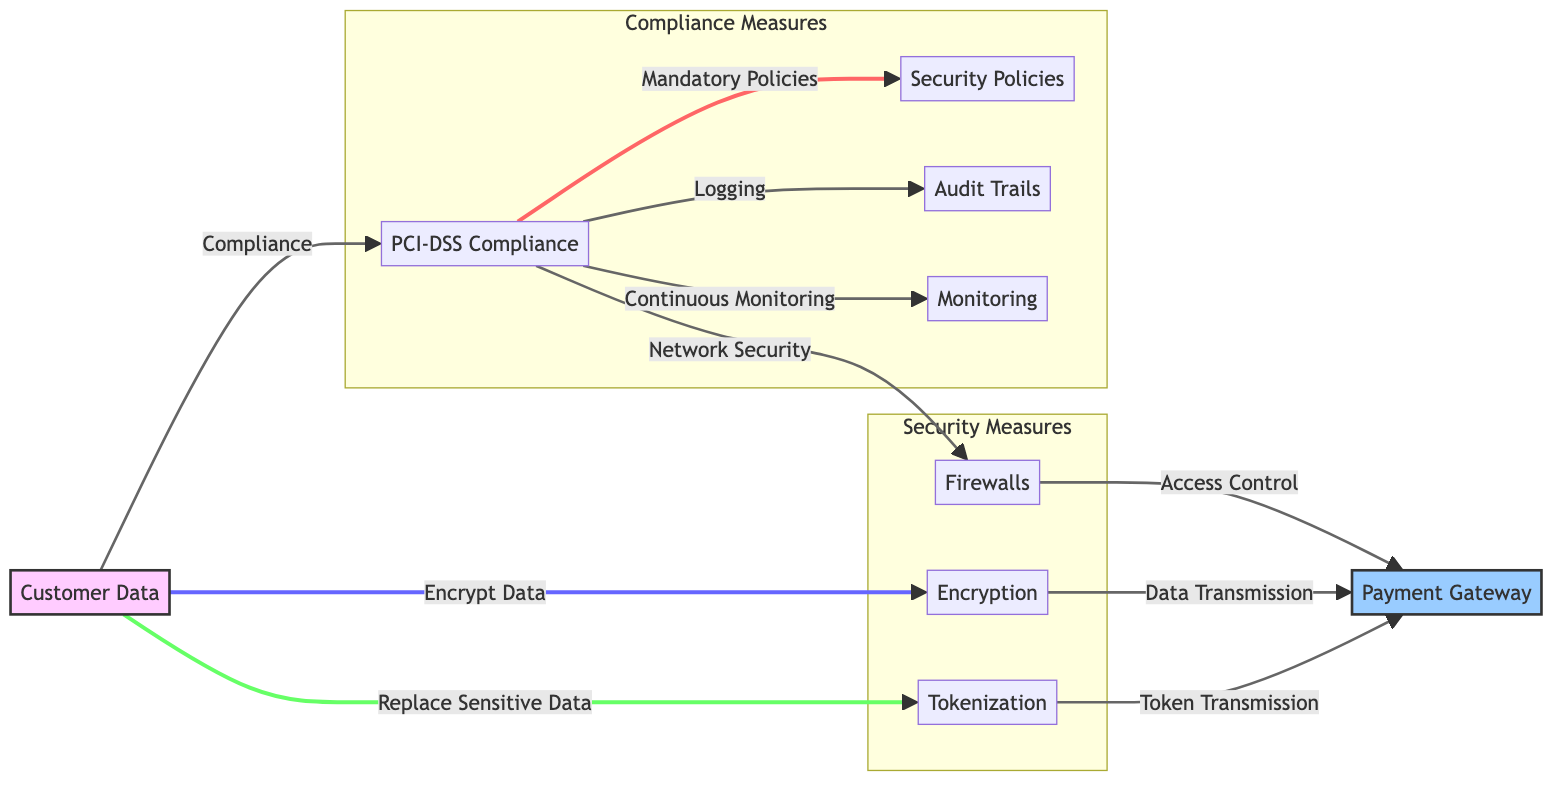What is the first security measure shown in the diagram? The first security measure is tokenization, which is directly connected to customer data and represents a way to replace sensitive data before transmission.
Answer: Tokenization How many compliance measures are depicted in the diagram? The diagram shows four compliance measures: PCI-DSS, security policies, audit trails, and monitoring, as indicated in the Compliance Measures subgraph.
Answer: Four What is the relationship between PCI-DSS and firewalls? PCI-DSS specifies network security, which includes implementing firewalls to protect the payment gateway, demonstrating a clear connection between compliance and security infrastructure.
Answer: Network Security What does customer data replace with tokenization? Customer data is replaced with sensitive data by tokenization, which is outlined in the flow from customer data to tokenization in the diagram.
Answer: Sensitive Data Which security measure is listed under the Security Measures subgraph? The subgraph contains tokenization, encryption, and firewalls, reflecting the primary security protocols needed in payment gateway integration.
Answer: Tokenization, Encryption, and Firewalls How is data transmitted securely according to the diagram? Data is transmitted securely through encryption methods, which ensure that the data remains confidential as it moves from the customer to the payment gateway.
Answer: Encryption What is required for continuous monitoring as per the diagram? Continuous monitoring is a requirement outlined by PCI-DSS, indicating that maintaining security measures must be an ongoing process in payment gateway integrations.
Answer: Continuous Monitoring What does PCI-DSS require for logging? PCI-DSS requires audit trails for logging, indicating that capturing and retaining logs is essential for compliance with payment security standards.
Answer: Audit Trails What type of control is associated with firewalls in the diagram? Firewalls are linked to access control, illustrating their role in managing who can access the payment gateway environment, which is critical for maintaining a secure infrastructure.
Answer: Access Control 